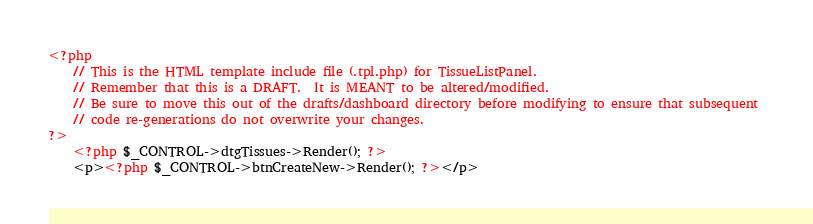Convert code to text. <code><loc_0><loc_0><loc_500><loc_500><_PHP_><?php
	// This is the HTML template include file (.tpl.php) for TissueListPanel.
	// Remember that this is a DRAFT.  It is MEANT to be altered/modified.
	// Be sure to move this out of the drafts/dashboard directory before modifying to ensure that subsequent 
	// code re-generations do not overwrite your changes.
?>
	<?php $_CONTROL->dtgTissues->Render(); ?>
	<p><?php $_CONTROL->btnCreateNew->Render(); ?></p>
</code> 